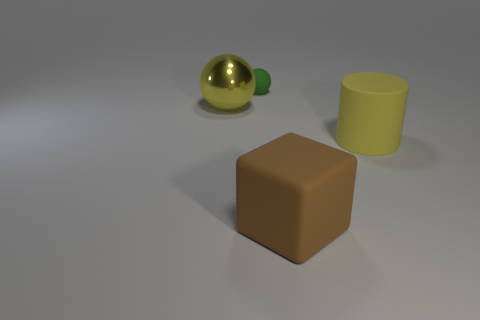Add 1 balls. How many objects exist? 5 Subtract all cylinders. How many objects are left? 3 Subtract 0 red cylinders. How many objects are left? 4 Subtract all cyan cubes. Subtract all green matte things. How many objects are left? 3 Add 1 tiny rubber things. How many tiny rubber things are left? 2 Add 3 purple cylinders. How many purple cylinders exist? 3 